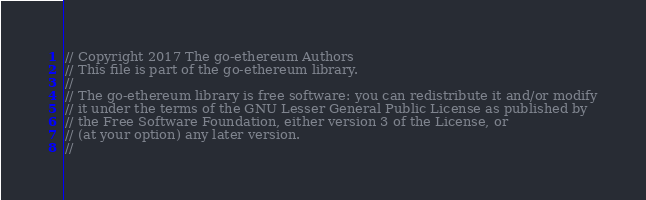<code> <loc_0><loc_0><loc_500><loc_500><_Go_>// Copyright 2017 The go-ethereum Authors
// This file is part of the go-ethereum library.
//
// The go-ethereum library is free software: you can redistribute it and/or modify
// it under the terms of the GNU Lesser General Public License as published by
// the Free Software Foundation, either version 3 of the License, or
// (at your option) any later version.
//</code> 